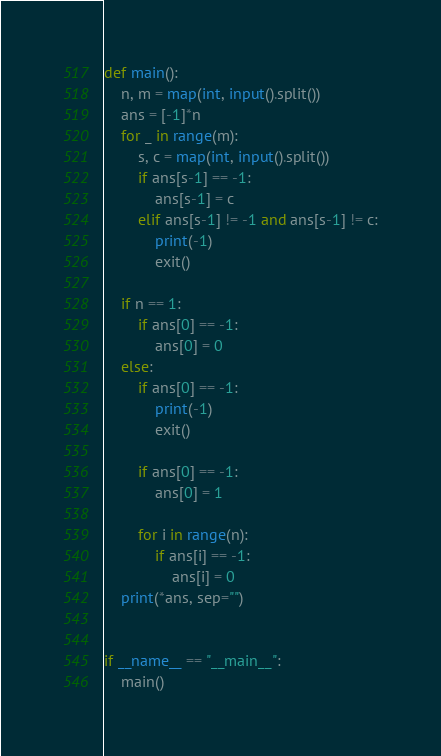Convert code to text. <code><loc_0><loc_0><loc_500><loc_500><_Python_>def main():
    n, m = map(int, input().split())
    ans = [-1]*n
    for _ in range(m):
        s, c = map(int, input().split())
        if ans[s-1] == -1:
            ans[s-1] = c
        elif ans[s-1] != -1 and ans[s-1] != c:
            print(-1)
            exit()

    if n == 1:
        if ans[0] == -1:
            ans[0] = 0
    else:
        if ans[0] == -1:
            print(-1)
            exit()

        if ans[0] == -1:
            ans[0] = 1

        for i in range(n):
            if ans[i] == -1:
                ans[i] = 0
    print(*ans, sep="")


if __name__ == "__main__":
    main()
</code> 